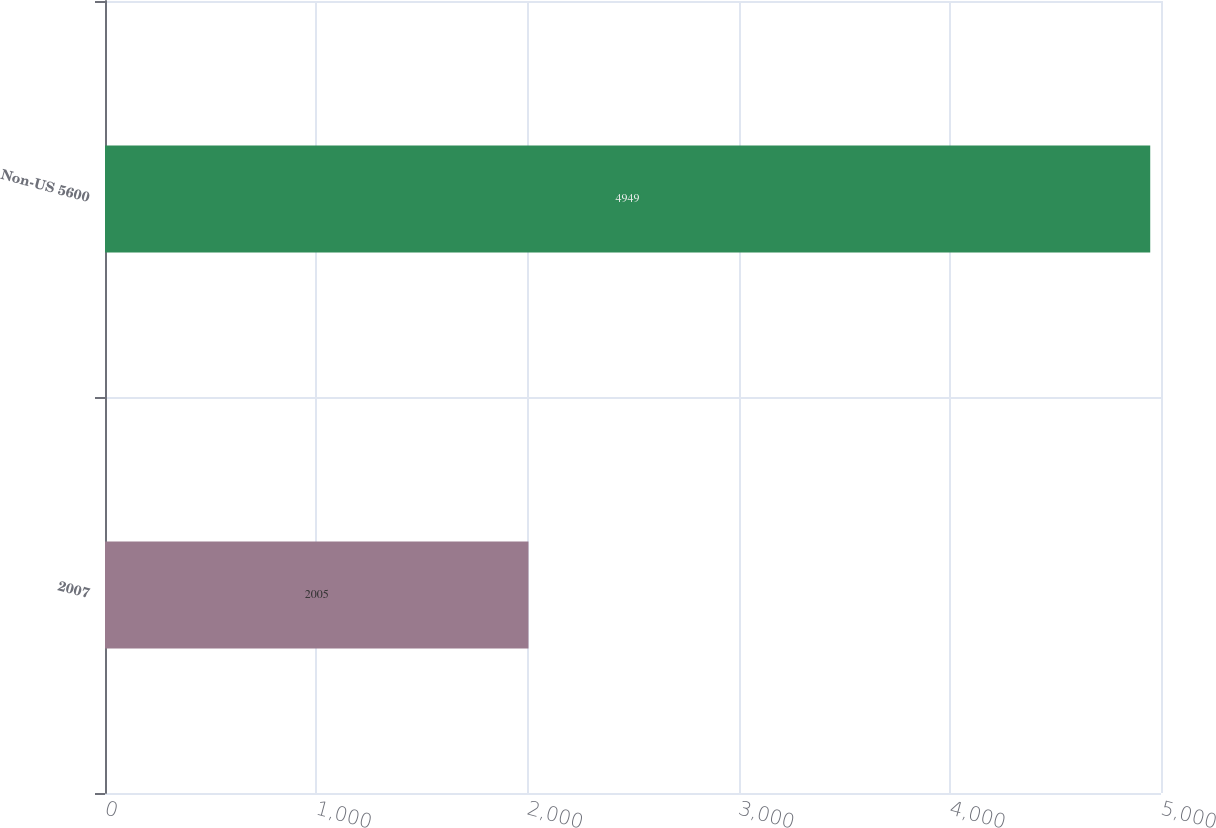<chart> <loc_0><loc_0><loc_500><loc_500><bar_chart><fcel>2007<fcel>Non-US 5600<nl><fcel>2005<fcel>4949<nl></chart> 